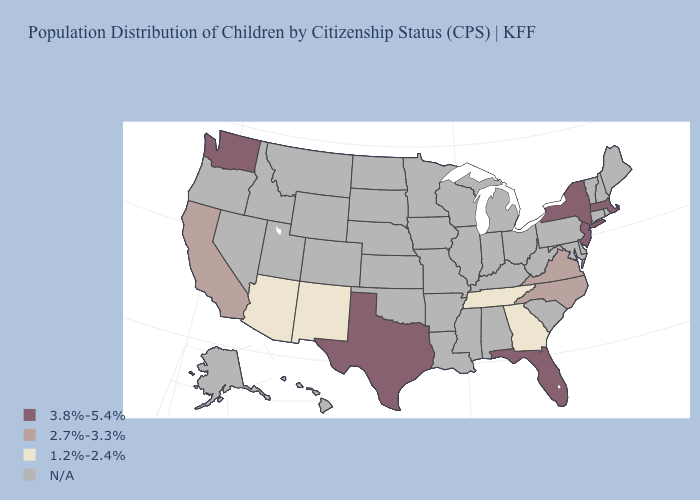Name the states that have a value in the range 2.7%-3.3%?
Write a very short answer. California, North Carolina, Virginia. What is the lowest value in the USA?
Give a very brief answer. 1.2%-2.4%. What is the value of Florida?
Concise answer only. 3.8%-5.4%. What is the value of New York?
Write a very short answer. 3.8%-5.4%. What is the value of Missouri?
Short answer required. N/A. Name the states that have a value in the range 1.2%-2.4%?
Write a very short answer. Arizona, Georgia, New Mexico, Tennessee. Does the first symbol in the legend represent the smallest category?
Write a very short answer. No. Name the states that have a value in the range 2.7%-3.3%?
Be succinct. California, North Carolina, Virginia. What is the value of Florida?
Give a very brief answer. 3.8%-5.4%. What is the value of Nevada?
Answer briefly. N/A. Name the states that have a value in the range 2.7%-3.3%?
Short answer required. California, North Carolina, Virginia. Does the map have missing data?
Quick response, please. Yes. Does the first symbol in the legend represent the smallest category?
Be succinct. No. 